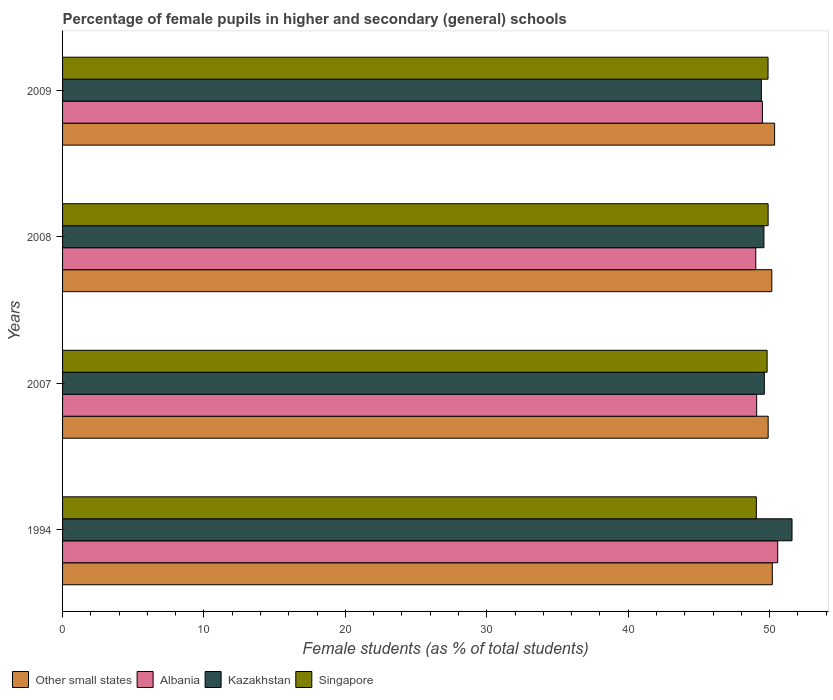How many groups of bars are there?
Give a very brief answer. 4. Are the number of bars per tick equal to the number of legend labels?
Your response must be concise. Yes. How many bars are there on the 3rd tick from the bottom?
Make the answer very short. 4. What is the label of the 3rd group of bars from the top?
Make the answer very short. 2007. What is the percentage of female pupils in higher and secondary schools in Other small states in 2007?
Ensure brevity in your answer.  49.89. Across all years, what is the maximum percentage of female pupils in higher and secondary schools in Other small states?
Keep it short and to the point. 50.35. Across all years, what is the minimum percentage of female pupils in higher and secondary schools in Kazakhstan?
Provide a succinct answer. 49.41. In which year was the percentage of female pupils in higher and secondary schools in Kazakhstan maximum?
Your response must be concise. 1994. What is the total percentage of female pupils in higher and secondary schools in Other small states in the graph?
Offer a terse response. 200.58. What is the difference between the percentage of female pupils in higher and secondary schools in Other small states in 2007 and that in 2009?
Keep it short and to the point. -0.46. What is the difference between the percentage of female pupils in higher and secondary schools in Albania in 1994 and the percentage of female pupils in higher and secondary schools in Kazakhstan in 2007?
Keep it short and to the point. 0.95. What is the average percentage of female pupils in higher and secondary schools in Other small states per year?
Keep it short and to the point. 50.14. In the year 2009, what is the difference between the percentage of female pupils in higher and secondary schools in Singapore and percentage of female pupils in higher and secondary schools in Kazakhstan?
Provide a succinct answer. 0.47. In how many years, is the percentage of female pupils in higher and secondary schools in Albania greater than 20 %?
Your response must be concise. 4. What is the ratio of the percentage of female pupils in higher and secondary schools in Other small states in 2007 to that in 2008?
Provide a short and direct response. 0.99. Is the percentage of female pupils in higher and secondary schools in Singapore in 2008 less than that in 2009?
Give a very brief answer. No. What is the difference between the highest and the second highest percentage of female pupils in higher and secondary schools in Other small states?
Offer a terse response. 0.16. What is the difference between the highest and the lowest percentage of female pupils in higher and secondary schools in Kazakhstan?
Your response must be concise. 2.17. Is the sum of the percentage of female pupils in higher and secondary schools in Other small states in 2007 and 2008 greater than the maximum percentage of female pupils in higher and secondary schools in Singapore across all years?
Offer a very short reply. Yes. What does the 2nd bar from the top in 1994 represents?
Provide a short and direct response. Kazakhstan. What does the 1st bar from the bottom in 2009 represents?
Offer a very short reply. Other small states. How many bars are there?
Ensure brevity in your answer.  16. Are all the bars in the graph horizontal?
Provide a succinct answer. Yes. What is the difference between two consecutive major ticks on the X-axis?
Make the answer very short. 10. Does the graph contain any zero values?
Ensure brevity in your answer.  No. Does the graph contain grids?
Give a very brief answer. No. Where does the legend appear in the graph?
Keep it short and to the point. Bottom left. How many legend labels are there?
Offer a terse response. 4. What is the title of the graph?
Your answer should be compact. Percentage of female pupils in higher and secondary (general) schools. Does "Namibia" appear as one of the legend labels in the graph?
Provide a succinct answer. No. What is the label or title of the X-axis?
Your response must be concise. Female students (as % of total students). What is the Female students (as % of total students) of Other small states in 1994?
Provide a short and direct response. 50.19. What is the Female students (as % of total students) of Albania in 1994?
Offer a very short reply. 50.57. What is the Female students (as % of total students) in Kazakhstan in 1994?
Your answer should be very brief. 51.58. What is the Female students (as % of total students) in Singapore in 1994?
Give a very brief answer. 49.06. What is the Female students (as % of total students) of Other small states in 2007?
Keep it short and to the point. 49.89. What is the Female students (as % of total students) of Albania in 2007?
Your answer should be very brief. 49.08. What is the Female students (as % of total students) in Kazakhstan in 2007?
Give a very brief answer. 49.62. What is the Female students (as % of total students) in Singapore in 2007?
Give a very brief answer. 49.82. What is the Female students (as % of total students) in Other small states in 2008?
Your response must be concise. 50.15. What is the Female students (as % of total students) in Albania in 2008?
Offer a terse response. 49.02. What is the Female students (as % of total students) in Kazakhstan in 2008?
Your answer should be compact. 49.59. What is the Female students (as % of total students) of Singapore in 2008?
Your answer should be compact. 49.89. What is the Female students (as % of total students) of Other small states in 2009?
Your response must be concise. 50.35. What is the Female students (as % of total students) of Albania in 2009?
Your response must be concise. 49.48. What is the Female students (as % of total students) in Kazakhstan in 2009?
Offer a very short reply. 49.41. What is the Female students (as % of total students) in Singapore in 2009?
Keep it short and to the point. 49.88. Across all years, what is the maximum Female students (as % of total students) in Other small states?
Keep it short and to the point. 50.35. Across all years, what is the maximum Female students (as % of total students) of Albania?
Offer a very short reply. 50.57. Across all years, what is the maximum Female students (as % of total students) of Kazakhstan?
Your answer should be compact. 51.58. Across all years, what is the maximum Female students (as % of total students) of Singapore?
Give a very brief answer. 49.89. Across all years, what is the minimum Female students (as % of total students) of Other small states?
Provide a short and direct response. 49.89. Across all years, what is the minimum Female students (as % of total students) in Albania?
Make the answer very short. 49.02. Across all years, what is the minimum Female students (as % of total students) of Kazakhstan?
Your answer should be very brief. 49.41. Across all years, what is the minimum Female students (as % of total students) in Singapore?
Your response must be concise. 49.06. What is the total Female students (as % of total students) of Other small states in the graph?
Provide a short and direct response. 200.58. What is the total Female students (as % of total students) of Albania in the graph?
Your answer should be compact. 198.15. What is the total Female students (as % of total students) in Kazakhstan in the graph?
Ensure brevity in your answer.  200.2. What is the total Female students (as % of total students) in Singapore in the graph?
Ensure brevity in your answer.  198.65. What is the difference between the Female students (as % of total students) in Other small states in 1994 and that in 2007?
Ensure brevity in your answer.  0.29. What is the difference between the Female students (as % of total students) in Albania in 1994 and that in 2007?
Offer a very short reply. 1.49. What is the difference between the Female students (as % of total students) of Kazakhstan in 1994 and that in 2007?
Keep it short and to the point. 1.96. What is the difference between the Female students (as % of total students) in Singapore in 1994 and that in 2007?
Give a very brief answer. -0.76. What is the difference between the Female students (as % of total students) of Other small states in 1994 and that in 2008?
Make the answer very short. 0.03. What is the difference between the Female students (as % of total students) of Albania in 1994 and that in 2008?
Make the answer very short. 1.55. What is the difference between the Female students (as % of total students) in Kazakhstan in 1994 and that in 2008?
Provide a short and direct response. 1.99. What is the difference between the Female students (as % of total students) of Singapore in 1994 and that in 2008?
Provide a short and direct response. -0.83. What is the difference between the Female students (as % of total students) in Other small states in 1994 and that in 2009?
Your answer should be compact. -0.16. What is the difference between the Female students (as % of total students) in Albania in 1994 and that in 2009?
Your answer should be compact. 1.08. What is the difference between the Female students (as % of total students) of Kazakhstan in 1994 and that in 2009?
Provide a short and direct response. 2.17. What is the difference between the Female students (as % of total students) of Singapore in 1994 and that in 2009?
Offer a very short reply. -0.83. What is the difference between the Female students (as % of total students) of Other small states in 2007 and that in 2008?
Your answer should be compact. -0.26. What is the difference between the Female students (as % of total students) of Albania in 2007 and that in 2008?
Ensure brevity in your answer.  0.06. What is the difference between the Female students (as % of total students) in Kazakhstan in 2007 and that in 2008?
Give a very brief answer. 0.03. What is the difference between the Female students (as % of total students) in Singapore in 2007 and that in 2008?
Ensure brevity in your answer.  -0.07. What is the difference between the Female students (as % of total students) in Other small states in 2007 and that in 2009?
Provide a short and direct response. -0.46. What is the difference between the Female students (as % of total students) of Albania in 2007 and that in 2009?
Ensure brevity in your answer.  -0.41. What is the difference between the Female students (as % of total students) of Kazakhstan in 2007 and that in 2009?
Make the answer very short. 0.21. What is the difference between the Female students (as % of total students) in Singapore in 2007 and that in 2009?
Your answer should be compact. -0.07. What is the difference between the Female students (as % of total students) of Other small states in 2008 and that in 2009?
Your answer should be very brief. -0.2. What is the difference between the Female students (as % of total students) of Albania in 2008 and that in 2009?
Give a very brief answer. -0.47. What is the difference between the Female students (as % of total students) of Kazakhstan in 2008 and that in 2009?
Your answer should be compact. 0.18. What is the difference between the Female students (as % of total students) of Singapore in 2008 and that in 2009?
Provide a short and direct response. 0. What is the difference between the Female students (as % of total students) of Other small states in 1994 and the Female students (as % of total students) of Albania in 2007?
Your response must be concise. 1.11. What is the difference between the Female students (as % of total students) in Other small states in 1994 and the Female students (as % of total students) in Kazakhstan in 2007?
Provide a succinct answer. 0.57. What is the difference between the Female students (as % of total students) of Other small states in 1994 and the Female students (as % of total students) of Singapore in 2007?
Your response must be concise. 0.37. What is the difference between the Female students (as % of total students) in Albania in 1994 and the Female students (as % of total students) in Kazakhstan in 2007?
Ensure brevity in your answer.  0.95. What is the difference between the Female students (as % of total students) of Albania in 1994 and the Female students (as % of total students) of Singapore in 2007?
Offer a terse response. 0.75. What is the difference between the Female students (as % of total students) of Kazakhstan in 1994 and the Female students (as % of total students) of Singapore in 2007?
Your response must be concise. 1.76. What is the difference between the Female students (as % of total students) in Other small states in 1994 and the Female students (as % of total students) in Albania in 2008?
Your response must be concise. 1.17. What is the difference between the Female students (as % of total students) of Other small states in 1994 and the Female students (as % of total students) of Kazakhstan in 2008?
Give a very brief answer. 0.59. What is the difference between the Female students (as % of total students) in Other small states in 1994 and the Female students (as % of total students) in Singapore in 2008?
Provide a succinct answer. 0.3. What is the difference between the Female students (as % of total students) of Albania in 1994 and the Female students (as % of total students) of Kazakhstan in 2008?
Offer a very short reply. 0.97. What is the difference between the Female students (as % of total students) of Albania in 1994 and the Female students (as % of total students) of Singapore in 2008?
Provide a short and direct response. 0.68. What is the difference between the Female students (as % of total students) in Kazakhstan in 1994 and the Female students (as % of total students) in Singapore in 2008?
Offer a terse response. 1.69. What is the difference between the Female students (as % of total students) of Other small states in 1994 and the Female students (as % of total students) of Albania in 2009?
Your answer should be very brief. 0.7. What is the difference between the Female students (as % of total students) in Other small states in 1994 and the Female students (as % of total students) in Kazakhstan in 2009?
Your answer should be very brief. 0.77. What is the difference between the Female students (as % of total students) of Other small states in 1994 and the Female students (as % of total students) of Singapore in 2009?
Give a very brief answer. 0.3. What is the difference between the Female students (as % of total students) of Albania in 1994 and the Female students (as % of total students) of Kazakhstan in 2009?
Provide a short and direct response. 1.16. What is the difference between the Female students (as % of total students) in Albania in 1994 and the Female students (as % of total students) in Singapore in 2009?
Provide a short and direct response. 0.68. What is the difference between the Female students (as % of total students) in Kazakhstan in 1994 and the Female students (as % of total students) in Singapore in 2009?
Your answer should be very brief. 1.7. What is the difference between the Female students (as % of total students) in Other small states in 2007 and the Female students (as % of total students) in Albania in 2008?
Provide a short and direct response. 0.88. What is the difference between the Female students (as % of total students) in Other small states in 2007 and the Female students (as % of total students) in Kazakhstan in 2008?
Your response must be concise. 0.3. What is the difference between the Female students (as % of total students) in Other small states in 2007 and the Female students (as % of total students) in Singapore in 2008?
Ensure brevity in your answer.  0. What is the difference between the Female students (as % of total students) in Albania in 2007 and the Female students (as % of total students) in Kazakhstan in 2008?
Provide a short and direct response. -0.51. What is the difference between the Female students (as % of total students) of Albania in 2007 and the Female students (as % of total students) of Singapore in 2008?
Ensure brevity in your answer.  -0.81. What is the difference between the Female students (as % of total students) of Kazakhstan in 2007 and the Female students (as % of total students) of Singapore in 2008?
Keep it short and to the point. -0.27. What is the difference between the Female students (as % of total students) in Other small states in 2007 and the Female students (as % of total students) in Albania in 2009?
Offer a terse response. 0.41. What is the difference between the Female students (as % of total students) of Other small states in 2007 and the Female students (as % of total students) of Kazakhstan in 2009?
Make the answer very short. 0.48. What is the difference between the Female students (as % of total students) in Other small states in 2007 and the Female students (as % of total students) in Singapore in 2009?
Keep it short and to the point. 0.01. What is the difference between the Female students (as % of total students) of Albania in 2007 and the Female students (as % of total students) of Kazakhstan in 2009?
Offer a very short reply. -0.33. What is the difference between the Female students (as % of total students) in Albania in 2007 and the Female students (as % of total students) in Singapore in 2009?
Provide a short and direct response. -0.8. What is the difference between the Female students (as % of total students) of Kazakhstan in 2007 and the Female students (as % of total students) of Singapore in 2009?
Provide a succinct answer. -0.26. What is the difference between the Female students (as % of total students) of Other small states in 2008 and the Female students (as % of total students) of Albania in 2009?
Make the answer very short. 0.67. What is the difference between the Female students (as % of total students) of Other small states in 2008 and the Female students (as % of total students) of Kazakhstan in 2009?
Ensure brevity in your answer.  0.74. What is the difference between the Female students (as % of total students) of Other small states in 2008 and the Female students (as % of total students) of Singapore in 2009?
Your response must be concise. 0.27. What is the difference between the Female students (as % of total students) of Albania in 2008 and the Female students (as % of total students) of Kazakhstan in 2009?
Your answer should be compact. -0.4. What is the difference between the Female students (as % of total students) in Albania in 2008 and the Female students (as % of total students) in Singapore in 2009?
Offer a very short reply. -0.87. What is the difference between the Female students (as % of total students) of Kazakhstan in 2008 and the Female students (as % of total students) of Singapore in 2009?
Your response must be concise. -0.29. What is the average Female students (as % of total students) of Other small states per year?
Offer a very short reply. 50.14. What is the average Female students (as % of total students) in Albania per year?
Your answer should be compact. 49.54. What is the average Female students (as % of total students) of Kazakhstan per year?
Ensure brevity in your answer.  50.05. What is the average Female students (as % of total students) of Singapore per year?
Offer a terse response. 49.66. In the year 1994, what is the difference between the Female students (as % of total students) of Other small states and Female students (as % of total students) of Albania?
Make the answer very short. -0.38. In the year 1994, what is the difference between the Female students (as % of total students) of Other small states and Female students (as % of total students) of Kazakhstan?
Offer a very short reply. -1.39. In the year 1994, what is the difference between the Female students (as % of total students) of Other small states and Female students (as % of total students) of Singapore?
Provide a succinct answer. 1.13. In the year 1994, what is the difference between the Female students (as % of total students) in Albania and Female students (as % of total students) in Kazakhstan?
Offer a very short reply. -1.01. In the year 1994, what is the difference between the Female students (as % of total students) in Albania and Female students (as % of total students) in Singapore?
Your answer should be compact. 1.51. In the year 1994, what is the difference between the Female students (as % of total students) of Kazakhstan and Female students (as % of total students) of Singapore?
Give a very brief answer. 2.52. In the year 2007, what is the difference between the Female students (as % of total students) in Other small states and Female students (as % of total students) in Albania?
Provide a short and direct response. 0.81. In the year 2007, what is the difference between the Female students (as % of total students) of Other small states and Female students (as % of total students) of Kazakhstan?
Provide a succinct answer. 0.27. In the year 2007, what is the difference between the Female students (as % of total students) of Other small states and Female students (as % of total students) of Singapore?
Provide a succinct answer. 0.07. In the year 2007, what is the difference between the Female students (as % of total students) of Albania and Female students (as % of total students) of Kazakhstan?
Ensure brevity in your answer.  -0.54. In the year 2007, what is the difference between the Female students (as % of total students) in Albania and Female students (as % of total students) in Singapore?
Your answer should be very brief. -0.74. In the year 2007, what is the difference between the Female students (as % of total students) in Kazakhstan and Female students (as % of total students) in Singapore?
Offer a terse response. -0.2. In the year 2008, what is the difference between the Female students (as % of total students) of Other small states and Female students (as % of total students) of Albania?
Keep it short and to the point. 1.13. In the year 2008, what is the difference between the Female students (as % of total students) of Other small states and Female students (as % of total students) of Kazakhstan?
Your answer should be compact. 0.56. In the year 2008, what is the difference between the Female students (as % of total students) in Other small states and Female students (as % of total students) in Singapore?
Ensure brevity in your answer.  0.26. In the year 2008, what is the difference between the Female students (as % of total students) of Albania and Female students (as % of total students) of Kazakhstan?
Ensure brevity in your answer.  -0.58. In the year 2008, what is the difference between the Female students (as % of total students) of Albania and Female students (as % of total students) of Singapore?
Offer a very short reply. -0.87. In the year 2008, what is the difference between the Female students (as % of total students) in Kazakhstan and Female students (as % of total students) in Singapore?
Provide a succinct answer. -0.3. In the year 2009, what is the difference between the Female students (as % of total students) of Other small states and Female students (as % of total students) of Albania?
Offer a terse response. 0.86. In the year 2009, what is the difference between the Female students (as % of total students) in Other small states and Female students (as % of total students) in Kazakhstan?
Make the answer very short. 0.94. In the year 2009, what is the difference between the Female students (as % of total students) in Other small states and Female students (as % of total students) in Singapore?
Provide a succinct answer. 0.46. In the year 2009, what is the difference between the Female students (as % of total students) in Albania and Female students (as % of total students) in Kazakhstan?
Provide a succinct answer. 0.07. In the year 2009, what is the difference between the Female students (as % of total students) of Albania and Female students (as % of total students) of Singapore?
Offer a terse response. -0.4. In the year 2009, what is the difference between the Female students (as % of total students) of Kazakhstan and Female students (as % of total students) of Singapore?
Provide a succinct answer. -0.47. What is the ratio of the Female students (as % of total students) in Other small states in 1994 to that in 2007?
Give a very brief answer. 1.01. What is the ratio of the Female students (as % of total students) of Albania in 1994 to that in 2007?
Provide a succinct answer. 1.03. What is the ratio of the Female students (as % of total students) in Kazakhstan in 1994 to that in 2007?
Give a very brief answer. 1.04. What is the ratio of the Female students (as % of total students) of Singapore in 1994 to that in 2007?
Your answer should be compact. 0.98. What is the ratio of the Female students (as % of total students) of Albania in 1994 to that in 2008?
Keep it short and to the point. 1.03. What is the ratio of the Female students (as % of total students) in Kazakhstan in 1994 to that in 2008?
Your answer should be compact. 1.04. What is the ratio of the Female students (as % of total students) in Singapore in 1994 to that in 2008?
Keep it short and to the point. 0.98. What is the ratio of the Female students (as % of total students) in Albania in 1994 to that in 2009?
Your answer should be compact. 1.02. What is the ratio of the Female students (as % of total students) of Kazakhstan in 1994 to that in 2009?
Provide a succinct answer. 1.04. What is the ratio of the Female students (as % of total students) of Singapore in 1994 to that in 2009?
Offer a terse response. 0.98. What is the ratio of the Female students (as % of total students) of Other small states in 2007 to that in 2008?
Offer a very short reply. 0.99. What is the ratio of the Female students (as % of total students) of Albania in 2007 to that in 2008?
Provide a short and direct response. 1. What is the ratio of the Female students (as % of total students) of Kazakhstan in 2007 to that in 2008?
Give a very brief answer. 1. What is the ratio of the Female students (as % of total students) of Singapore in 2007 to that in 2008?
Offer a terse response. 1. What is the ratio of the Female students (as % of total students) in Other small states in 2007 to that in 2009?
Offer a terse response. 0.99. What is the ratio of the Female students (as % of total students) of Singapore in 2007 to that in 2009?
Offer a very short reply. 1. What is the ratio of the Female students (as % of total students) in Other small states in 2008 to that in 2009?
Offer a very short reply. 1. What is the ratio of the Female students (as % of total students) in Albania in 2008 to that in 2009?
Offer a very short reply. 0.99. What is the ratio of the Female students (as % of total students) of Kazakhstan in 2008 to that in 2009?
Provide a short and direct response. 1. What is the ratio of the Female students (as % of total students) in Singapore in 2008 to that in 2009?
Your answer should be compact. 1. What is the difference between the highest and the second highest Female students (as % of total students) in Other small states?
Provide a succinct answer. 0.16. What is the difference between the highest and the second highest Female students (as % of total students) in Albania?
Offer a very short reply. 1.08. What is the difference between the highest and the second highest Female students (as % of total students) of Kazakhstan?
Make the answer very short. 1.96. What is the difference between the highest and the second highest Female students (as % of total students) in Singapore?
Give a very brief answer. 0. What is the difference between the highest and the lowest Female students (as % of total students) in Other small states?
Give a very brief answer. 0.46. What is the difference between the highest and the lowest Female students (as % of total students) in Albania?
Give a very brief answer. 1.55. What is the difference between the highest and the lowest Female students (as % of total students) of Kazakhstan?
Your response must be concise. 2.17. What is the difference between the highest and the lowest Female students (as % of total students) of Singapore?
Provide a succinct answer. 0.83. 